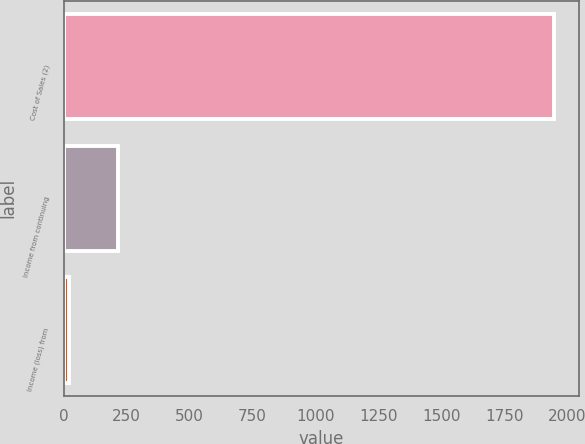Convert chart. <chart><loc_0><loc_0><loc_500><loc_500><bar_chart><fcel>Cost of Sales (2)<fcel>Income from continuing<fcel>Income (loss) from<nl><fcel>1947<fcel>214.5<fcel>22<nl></chart> 